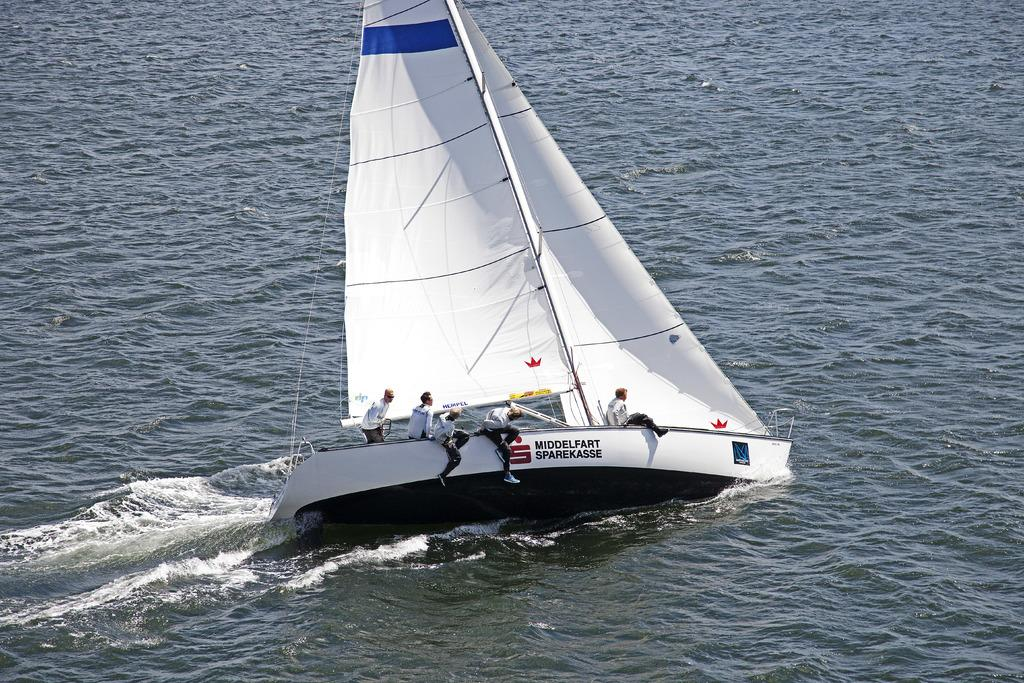Who is present in the image? There are people in the image. What are the people doing in the image? The people are sitting in a yacht. What can be seen in the background of the image? There is water visible in the image. What type of water might the people be on? The water might be a sea. What type of letters can be seen on the yacht in the image? There are no letters visible on the yacht in the image. How does the zipper on the yacht work in the image? There is no zipper present on the yacht in the image. 